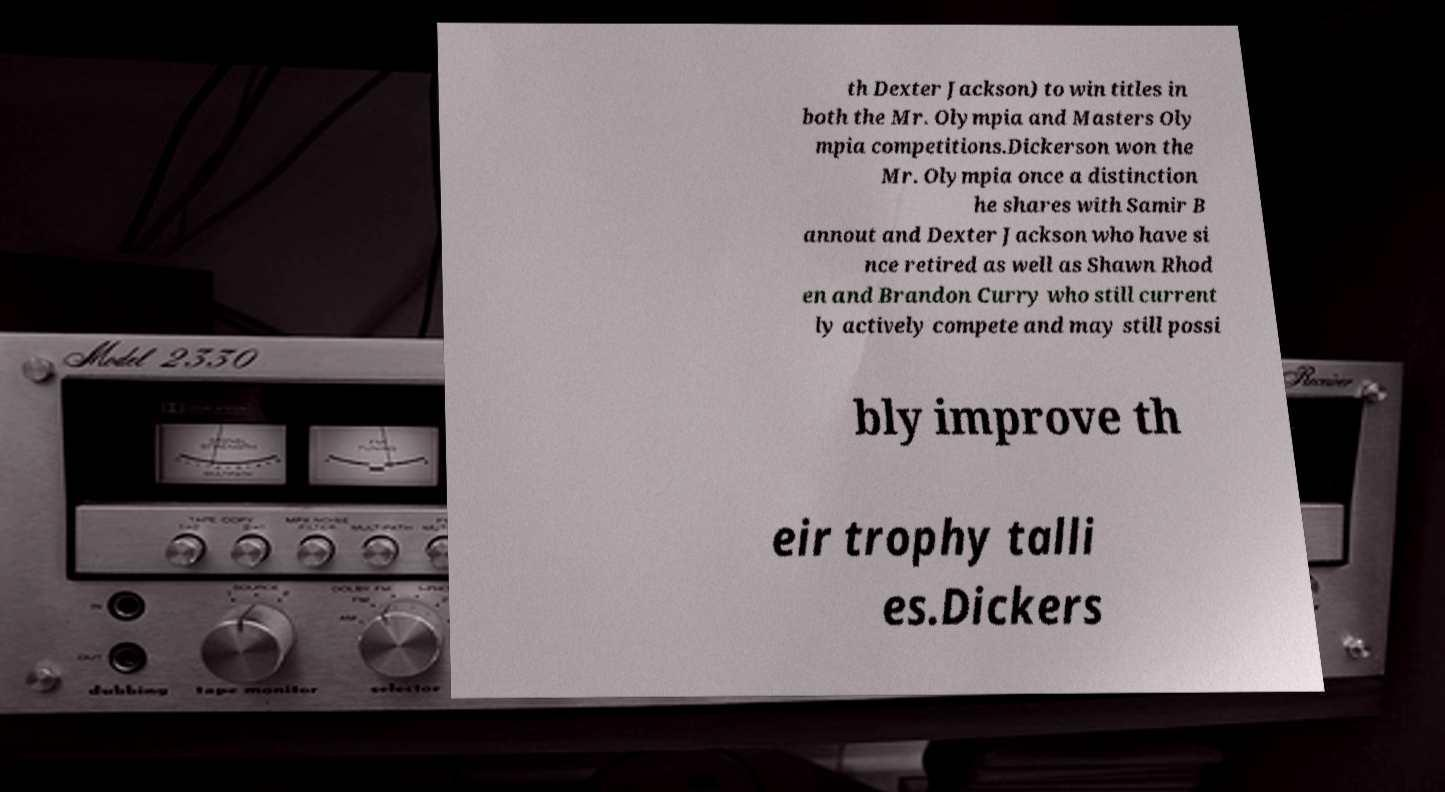Please identify and transcribe the text found in this image. th Dexter Jackson) to win titles in both the Mr. Olympia and Masters Oly mpia competitions.Dickerson won the Mr. Olympia once a distinction he shares with Samir B annout and Dexter Jackson who have si nce retired as well as Shawn Rhod en and Brandon Curry who still current ly actively compete and may still possi bly improve th eir trophy talli es.Dickers 